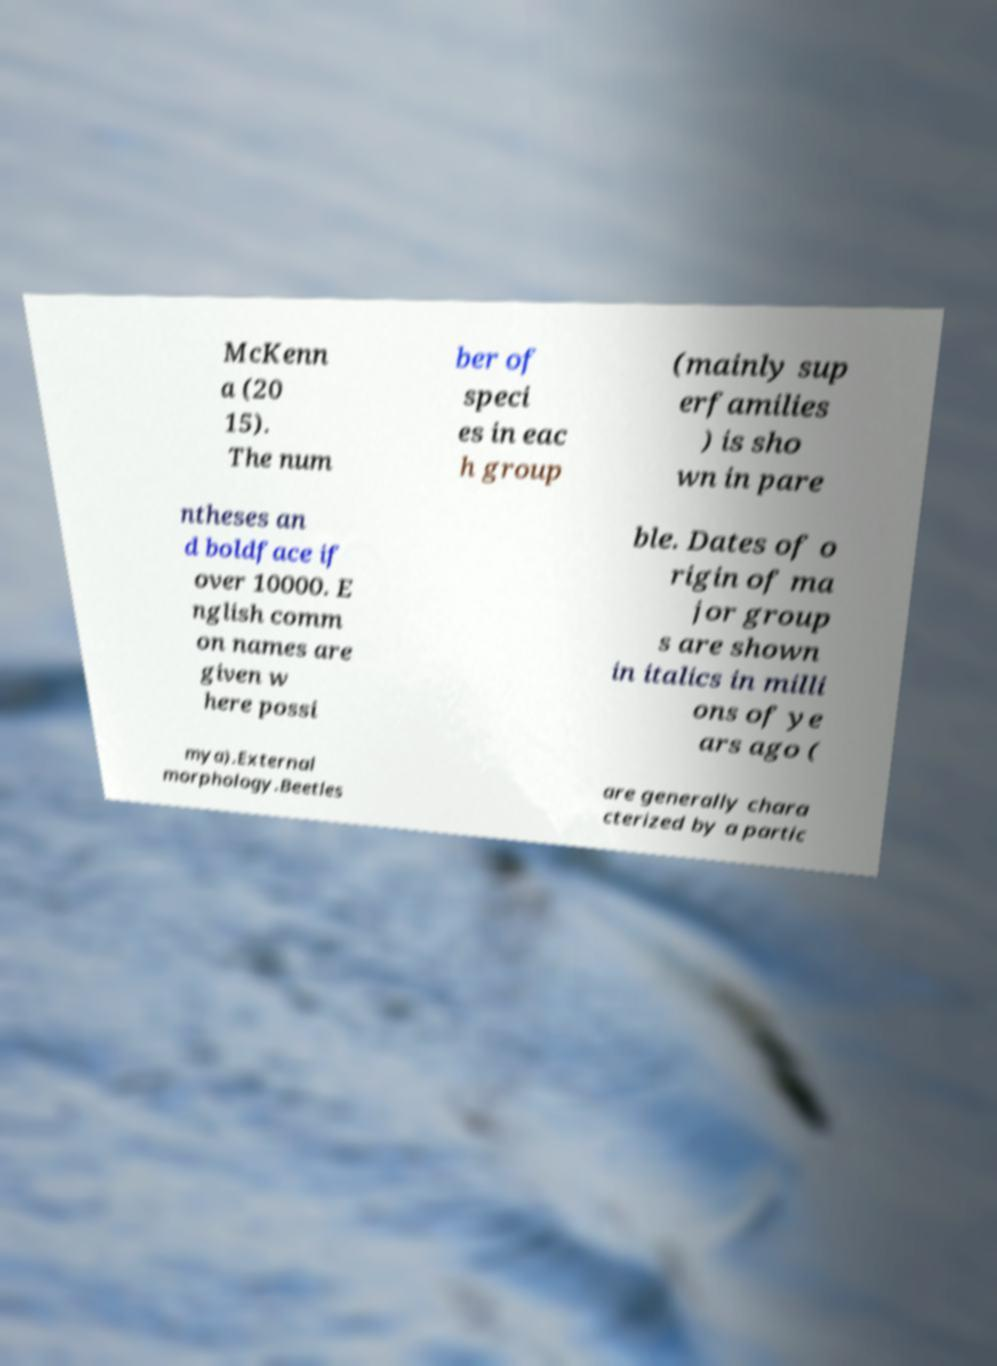Please identify and transcribe the text found in this image. McKenn a (20 15). The num ber of speci es in eac h group (mainly sup erfamilies ) is sho wn in pare ntheses an d boldface if over 10000. E nglish comm on names are given w here possi ble. Dates of o rigin of ma jor group s are shown in italics in milli ons of ye ars ago ( mya).External morphology.Beetles are generally chara cterized by a partic 